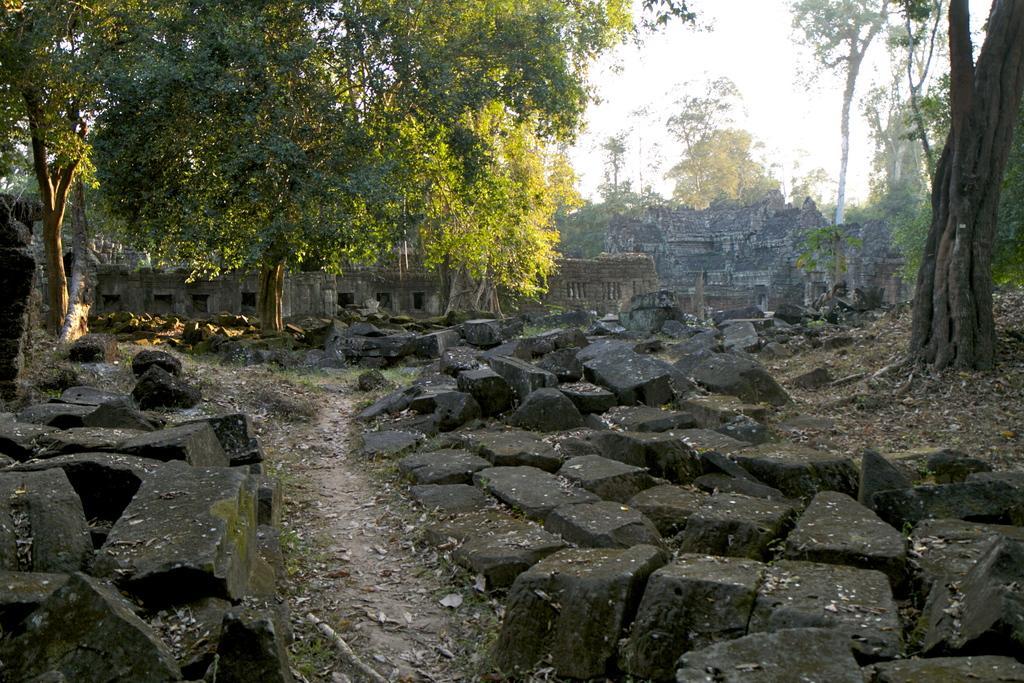In one or two sentences, can you explain what this image depicts? In the picture we can see a surface which is covered with stones which are black in color and some far away from it we can see two trees and some rocks near it and behind it we can see a old wall and in the background also we can see some old constructions, trees and behind it we can see a sky. 